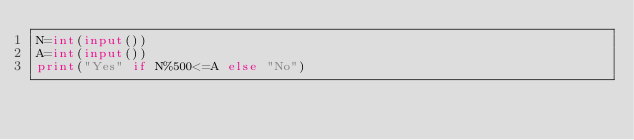<code> <loc_0><loc_0><loc_500><loc_500><_Python_>N=int(input())
A=int(input())
print("Yes" if N%500<=A else "No")
</code> 